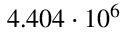Convert formula to latex. <formula><loc_0><loc_0><loc_500><loc_500>4 . 4 0 4 \cdot 1 0 ^ { 6 }</formula> 